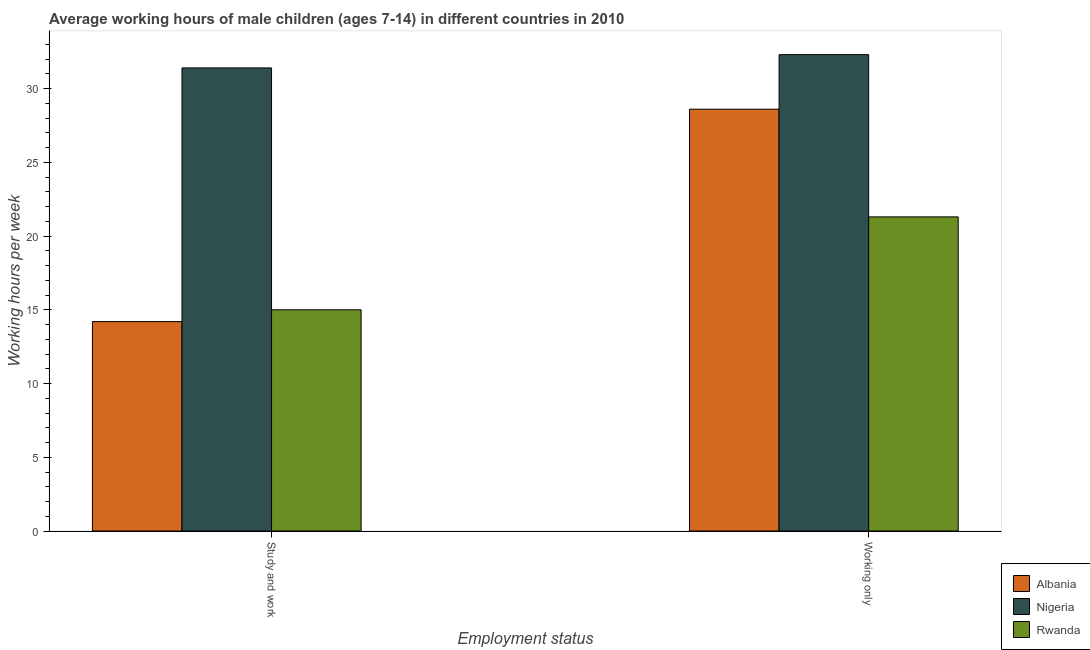Are the number of bars on each tick of the X-axis equal?
Give a very brief answer. Yes. How many bars are there on the 2nd tick from the left?
Offer a terse response. 3. How many bars are there on the 2nd tick from the right?
Your answer should be very brief. 3. What is the label of the 1st group of bars from the left?
Your answer should be compact. Study and work. What is the average working hour of children involved in only work in Nigeria?
Make the answer very short. 32.3. Across all countries, what is the maximum average working hour of children involved in study and work?
Provide a succinct answer. 31.4. In which country was the average working hour of children involved in only work maximum?
Provide a short and direct response. Nigeria. In which country was the average working hour of children involved in study and work minimum?
Offer a terse response. Albania. What is the total average working hour of children involved in only work in the graph?
Make the answer very short. 82.2. What is the difference between the average working hour of children involved in only work in Nigeria and that in Rwanda?
Provide a succinct answer. 11. What is the difference between the average working hour of children involved in study and work in Nigeria and the average working hour of children involved in only work in Albania?
Offer a terse response. 2.8. What is the average average working hour of children involved in study and work per country?
Keep it short and to the point. 20.2. What is the difference between the average working hour of children involved in study and work and average working hour of children involved in only work in Rwanda?
Offer a very short reply. -6.3. What is the ratio of the average working hour of children involved in only work in Rwanda to that in Albania?
Offer a very short reply. 0.74. Is the average working hour of children involved in study and work in Albania less than that in Rwanda?
Your answer should be compact. Yes. What does the 1st bar from the left in Study and work represents?
Your answer should be very brief. Albania. What does the 3rd bar from the right in Working only represents?
Offer a very short reply. Albania. How many bars are there?
Provide a short and direct response. 6. Are all the bars in the graph horizontal?
Provide a succinct answer. No. What is the difference between two consecutive major ticks on the Y-axis?
Give a very brief answer. 5. Are the values on the major ticks of Y-axis written in scientific E-notation?
Provide a short and direct response. No. Does the graph contain any zero values?
Provide a short and direct response. No. Does the graph contain grids?
Offer a terse response. No. Where does the legend appear in the graph?
Offer a terse response. Bottom right. What is the title of the graph?
Make the answer very short. Average working hours of male children (ages 7-14) in different countries in 2010. What is the label or title of the X-axis?
Your answer should be compact. Employment status. What is the label or title of the Y-axis?
Offer a terse response. Working hours per week. What is the Working hours per week in Albania in Study and work?
Your response must be concise. 14.2. What is the Working hours per week of Nigeria in Study and work?
Provide a short and direct response. 31.4. What is the Working hours per week in Rwanda in Study and work?
Make the answer very short. 15. What is the Working hours per week of Albania in Working only?
Offer a terse response. 28.6. What is the Working hours per week in Nigeria in Working only?
Offer a very short reply. 32.3. What is the Working hours per week of Rwanda in Working only?
Ensure brevity in your answer.  21.3. Across all Employment status, what is the maximum Working hours per week of Albania?
Give a very brief answer. 28.6. Across all Employment status, what is the maximum Working hours per week of Nigeria?
Ensure brevity in your answer.  32.3. Across all Employment status, what is the maximum Working hours per week of Rwanda?
Keep it short and to the point. 21.3. Across all Employment status, what is the minimum Working hours per week of Albania?
Keep it short and to the point. 14.2. Across all Employment status, what is the minimum Working hours per week in Nigeria?
Provide a succinct answer. 31.4. What is the total Working hours per week of Albania in the graph?
Ensure brevity in your answer.  42.8. What is the total Working hours per week of Nigeria in the graph?
Your answer should be very brief. 63.7. What is the total Working hours per week of Rwanda in the graph?
Your answer should be compact. 36.3. What is the difference between the Working hours per week in Albania in Study and work and that in Working only?
Your answer should be compact. -14.4. What is the difference between the Working hours per week of Rwanda in Study and work and that in Working only?
Provide a short and direct response. -6.3. What is the difference between the Working hours per week of Albania in Study and work and the Working hours per week of Nigeria in Working only?
Provide a succinct answer. -18.1. What is the difference between the Working hours per week in Albania in Study and work and the Working hours per week in Rwanda in Working only?
Your answer should be very brief. -7.1. What is the difference between the Working hours per week of Nigeria in Study and work and the Working hours per week of Rwanda in Working only?
Offer a very short reply. 10.1. What is the average Working hours per week of Albania per Employment status?
Ensure brevity in your answer.  21.4. What is the average Working hours per week of Nigeria per Employment status?
Provide a short and direct response. 31.85. What is the average Working hours per week in Rwanda per Employment status?
Your answer should be compact. 18.15. What is the difference between the Working hours per week of Albania and Working hours per week of Nigeria in Study and work?
Provide a succinct answer. -17.2. What is the difference between the Working hours per week of Albania and Working hours per week of Rwanda in Study and work?
Offer a very short reply. -0.8. What is the difference between the Working hours per week in Albania and Working hours per week in Nigeria in Working only?
Give a very brief answer. -3.7. What is the difference between the Working hours per week of Albania and Working hours per week of Rwanda in Working only?
Offer a terse response. 7.3. What is the difference between the Working hours per week in Nigeria and Working hours per week in Rwanda in Working only?
Your response must be concise. 11. What is the ratio of the Working hours per week of Albania in Study and work to that in Working only?
Offer a terse response. 0.5. What is the ratio of the Working hours per week in Nigeria in Study and work to that in Working only?
Your answer should be very brief. 0.97. What is the ratio of the Working hours per week in Rwanda in Study and work to that in Working only?
Offer a very short reply. 0.7. What is the difference between the highest and the second highest Working hours per week of Albania?
Provide a short and direct response. 14.4. What is the difference between the highest and the second highest Working hours per week of Nigeria?
Offer a terse response. 0.9. What is the difference between the highest and the lowest Working hours per week in Albania?
Keep it short and to the point. 14.4. What is the difference between the highest and the lowest Working hours per week in Rwanda?
Provide a short and direct response. 6.3. 